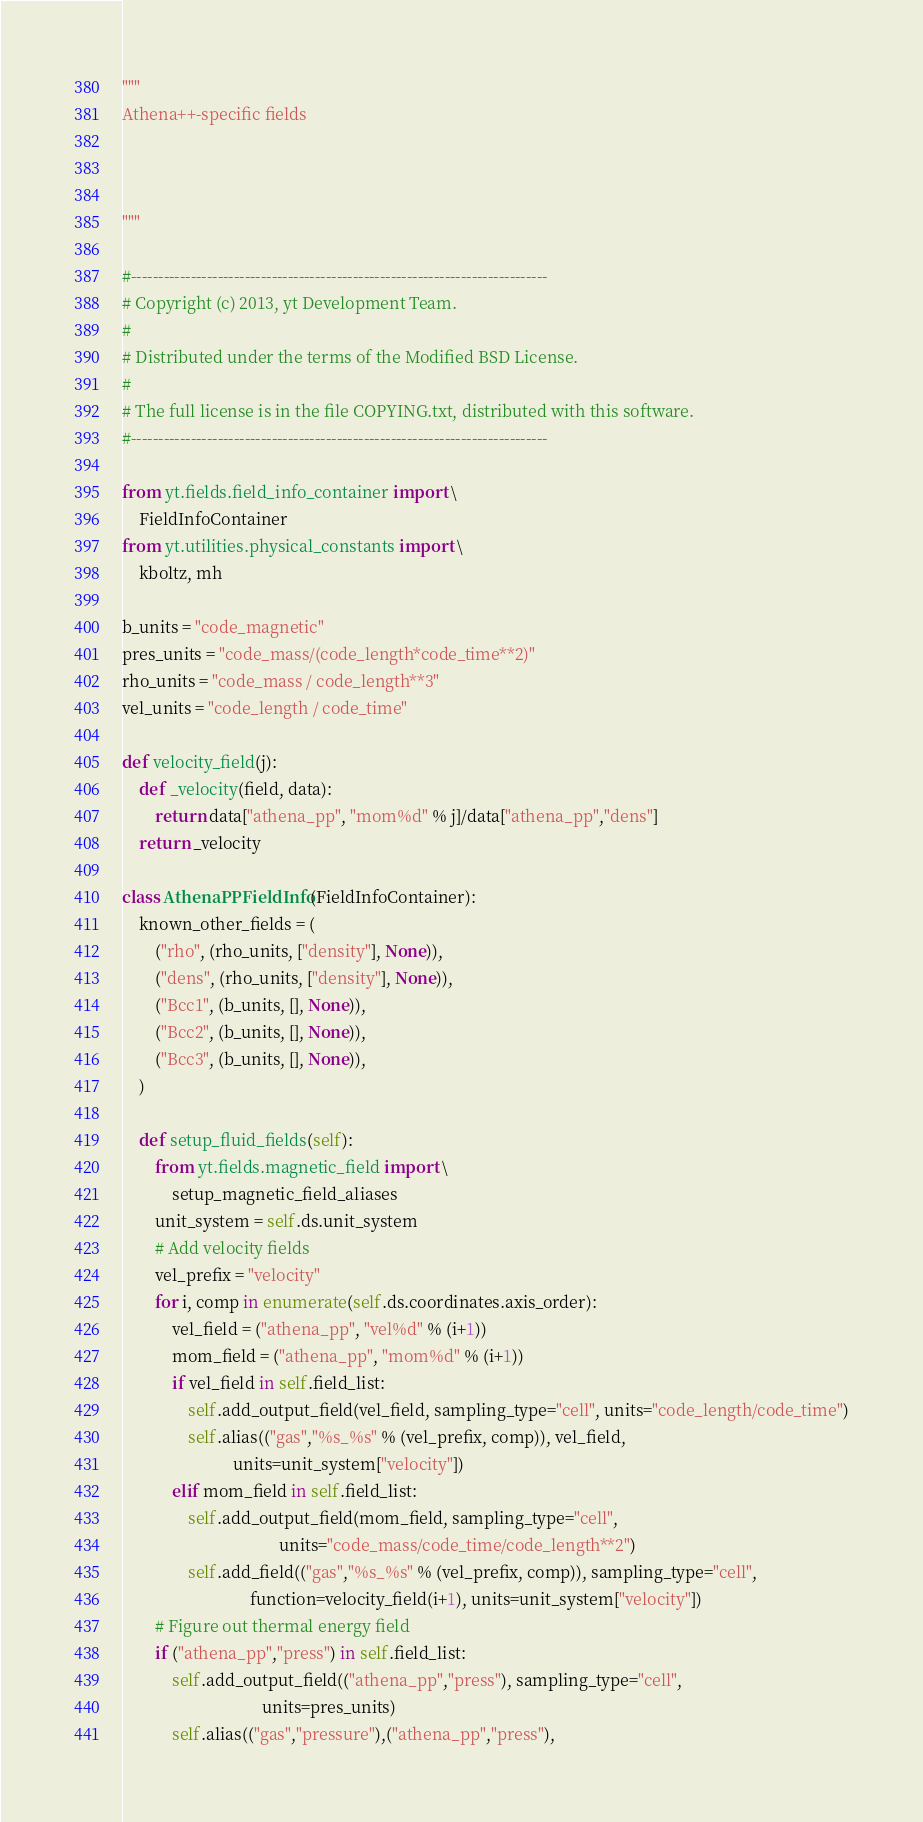<code> <loc_0><loc_0><loc_500><loc_500><_Python_>"""
Athena++-specific fields



"""

#-----------------------------------------------------------------------------
# Copyright (c) 2013, yt Development Team.
#
# Distributed under the terms of the Modified BSD License.
#
# The full license is in the file COPYING.txt, distributed with this software.
#-----------------------------------------------------------------------------

from yt.fields.field_info_container import \
    FieldInfoContainer
from yt.utilities.physical_constants import \
    kboltz, mh

b_units = "code_magnetic"
pres_units = "code_mass/(code_length*code_time**2)"
rho_units = "code_mass / code_length**3"
vel_units = "code_length / code_time"

def velocity_field(j):
    def _velocity(field, data):
        return data["athena_pp", "mom%d" % j]/data["athena_pp","dens"]
    return _velocity

class AthenaPPFieldInfo(FieldInfoContainer):
    known_other_fields = (
        ("rho", (rho_units, ["density"], None)),
        ("dens", (rho_units, ["density"], None)),
        ("Bcc1", (b_units, [], None)),
        ("Bcc2", (b_units, [], None)),
        ("Bcc3", (b_units, [], None)),
    )

    def setup_fluid_fields(self):
        from yt.fields.magnetic_field import \
            setup_magnetic_field_aliases
        unit_system = self.ds.unit_system
        # Add velocity fields
        vel_prefix = "velocity"
        for i, comp in enumerate(self.ds.coordinates.axis_order):
            vel_field = ("athena_pp", "vel%d" % (i+1))
            mom_field = ("athena_pp", "mom%d" % (i+1))
            if vel_field in self.field_list:
                self.add_output_field(vel_field, sampling_type="cell", units="code_length/code_time")
                self.alias(("gas","%s_%s" % (vel_prefix, comp)), vel_field,
                           units=unit_system["velocity"])
            elif mom_field in self.field_list:
                self.add_output_field(mom_field, sampling_type="cell",
                                      units="code_mass/code_time/code_length**2")
                self.add_field(("gas","%s_%s" % (vel_prefix, comp)), sampling_type="cell",
                               function=velocity_field(i+1), units=unit_system["velocity"])
        # Figure out thermal energy field
        if ("athena_pp","press") in self.field_list:
            self.add_output_field(("athena_pp","press"), sampling_type="cell",
                                  units=pres_units)
            self.alias(("gas","pressure"),("athena_pp","press"),</code> 